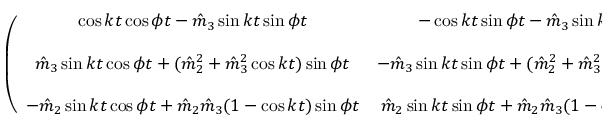Convert formula to latex. <formula><loc_0><loc_0><loc_500><loc_500>\begin{array} { r } { \left ( \begin{array} { c c c } { \cos k t \cos \phi t - \hat { m } _ { 3 } \sin k t \sin \phi t } & { - \cos k t \sin \phi t - \hat { m } _ { 3 } \sin k t \cos \phi t } & { \hat { m } _ { 2 } \sin k t } \\ { \hat { m } _ { 3 } \sin k t \cos \phi t + ( \hat { m } _ { 2 } ^ { 2 } + \hat { m } _ { 3 } ^ { 2 } \cos k t ) \sin \phi t } & { - \hat { m } _ { 3 } \sin k t \sin \phi t + ( \hat { m } _ { 2 } ^ { 2 } + \hat { m } _ { 3 } ^ { 2 } \cos k t ) \cos \phi t } & { \hat { m } _ { 2 } \hat { m } _ { 3 } ( 1 - \cos k t ) } \\ { - \hat { m } _ { 2 } \sin k t \cos \phi t + \hat { m } _ { 2 } \hat { m } _ { 3 } ( 1 - \cos k t ) \sin \phi t } & { \hat { m } _ { 2 } \sin k t \sin \phi t + \hat { m } _ { 2 } \hat { m } _ { 3 } ( 1 - \cos k t ) \cos \phi t } & { \hat { m } _ { 3 } ^ { 2 } + \hat { m } _ { 2 } ^ { 2 } \cos k t } \end{array} \right ) } \end{array}</formula> 